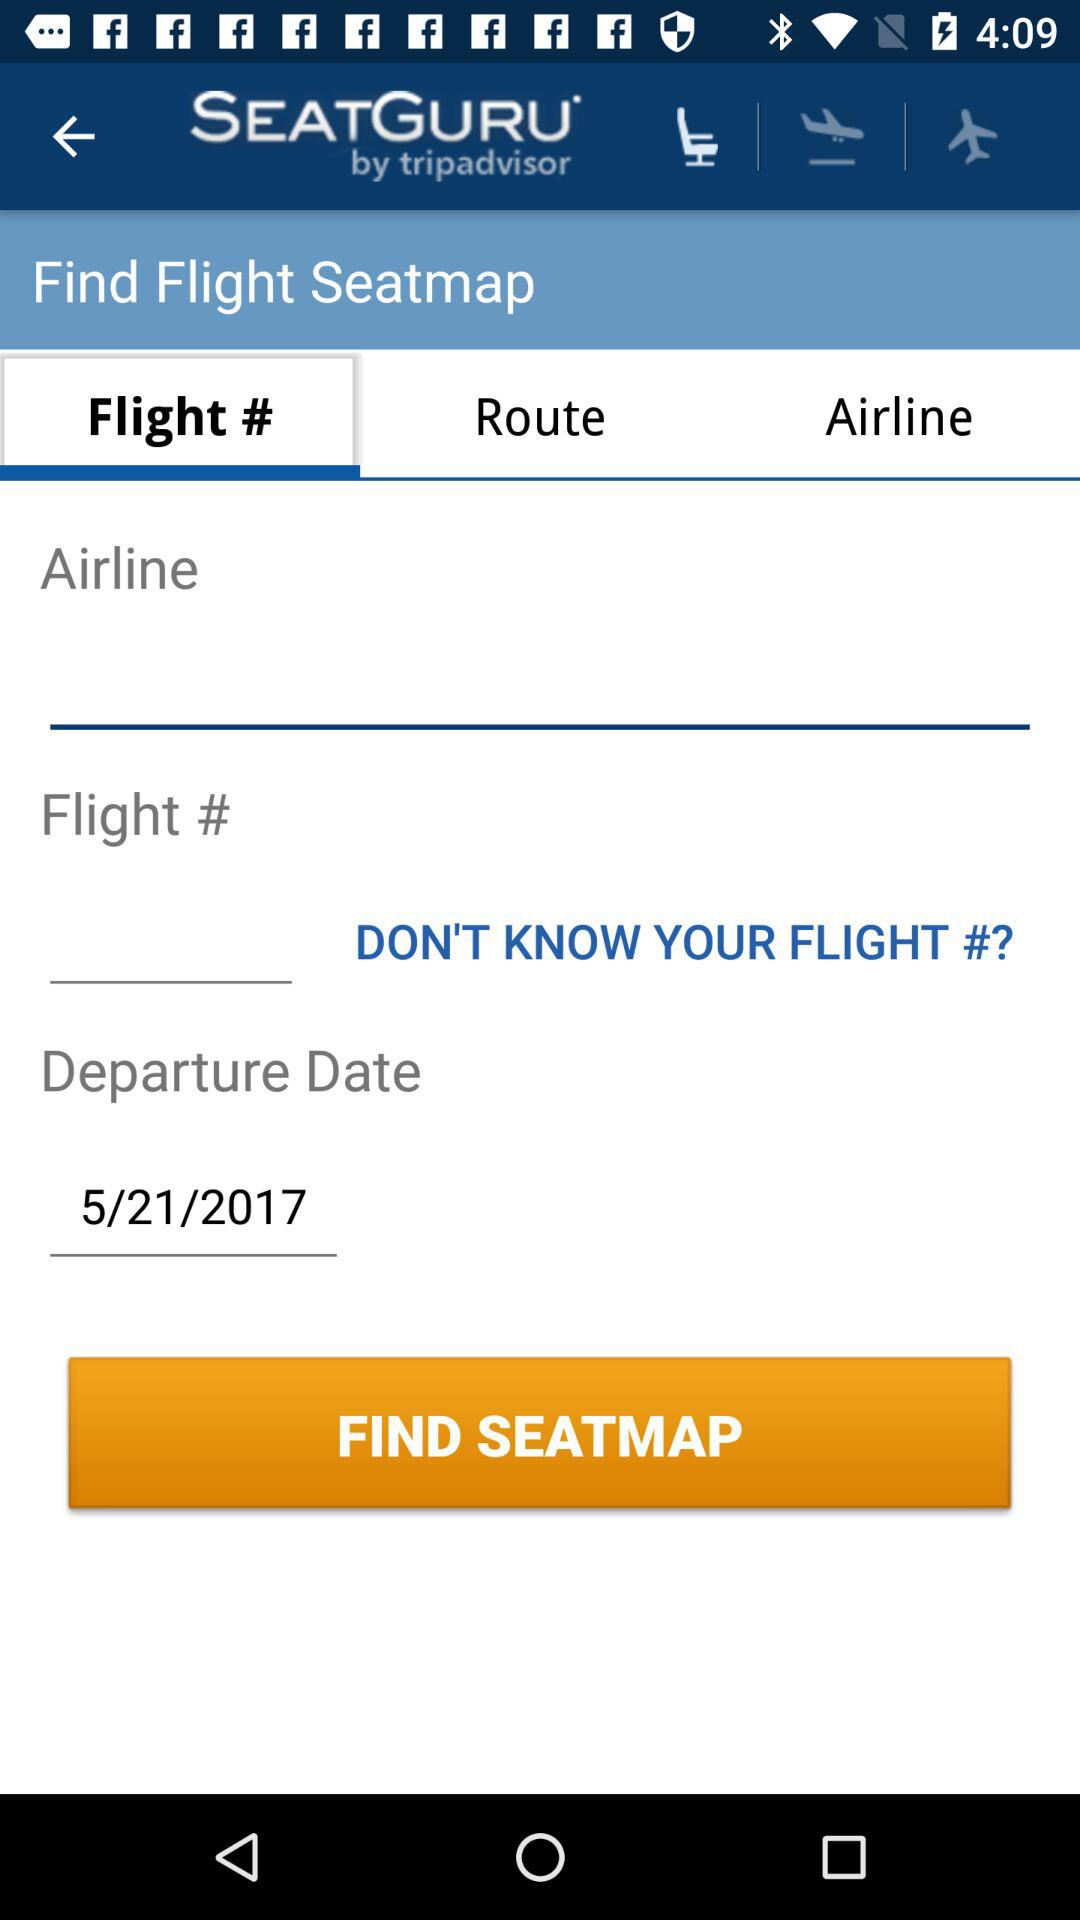Which option is selected? The selected option is "Flight #". 